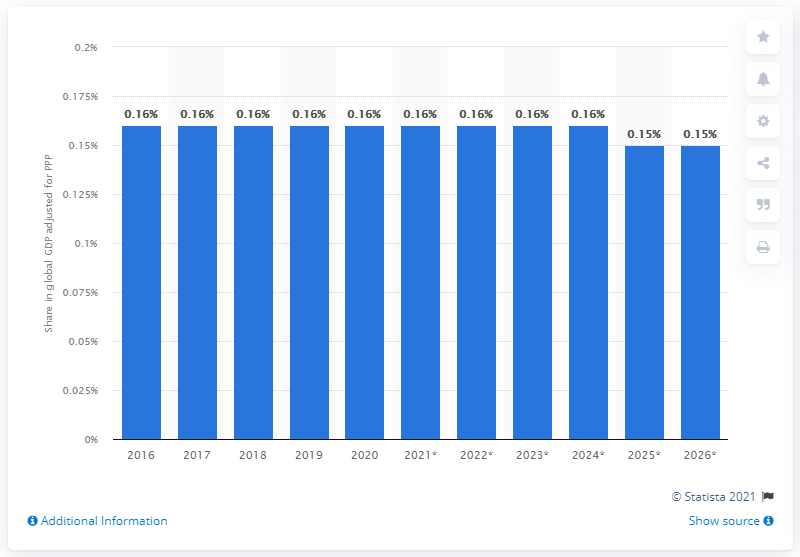Mention a couple of crucial points in this snapshot. In 2020, New Zealand's share of the global gross domestic product when adjusted for Purchasing Power Parity was 0.16%. 